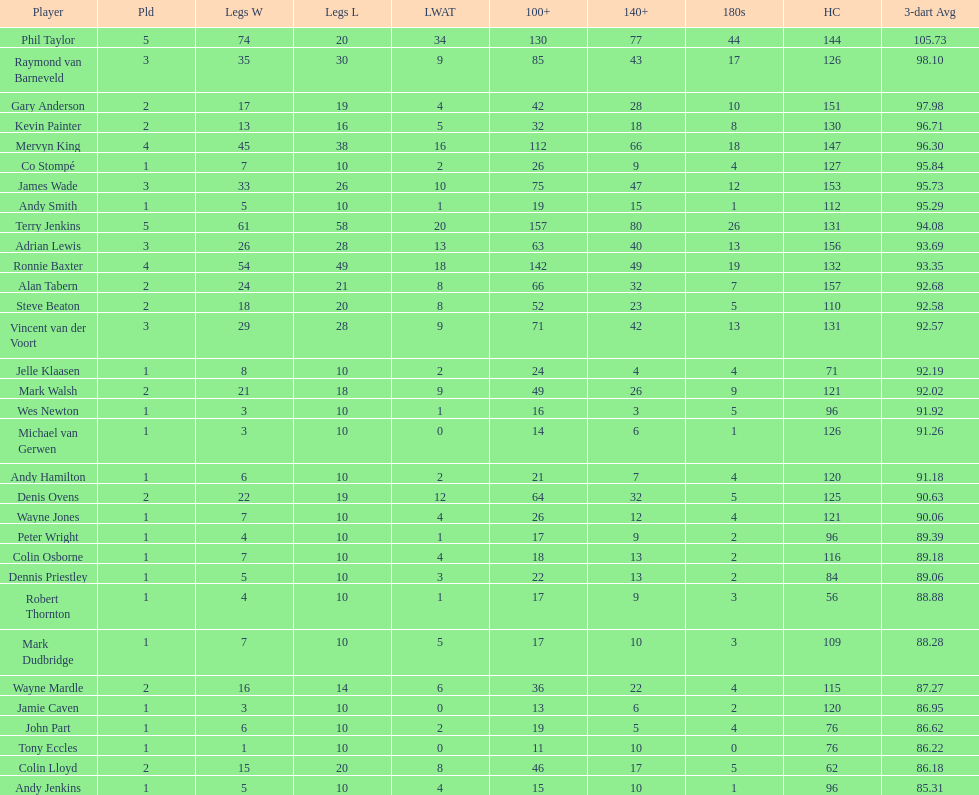How many players have a 3 dart average of more than 97? 3. 